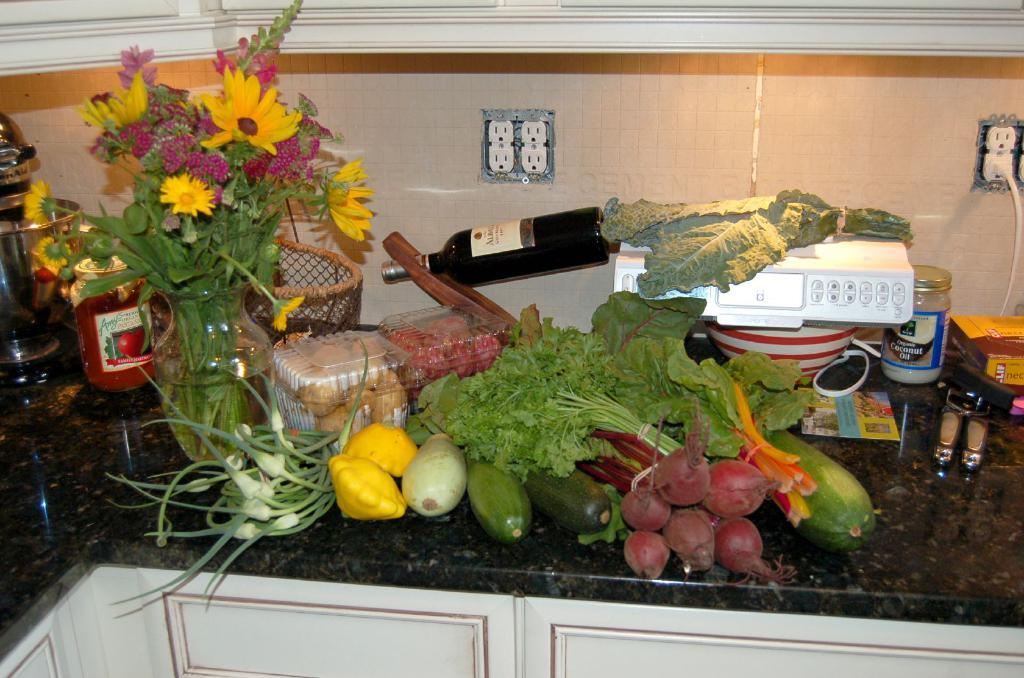What type of food items can be seen in the image? There are vegetables in the image. What type of containers are present in the image? There are boxes in the image. What device is used for measuring weight in the image? There is a weighing machine in the image. What type of decorative item is present in the image? There is a flower vase in the image. What type of liquid containers are on the counter top? There are bottles on the counter top. What type of storage furniture is present in the image? There are cupboards in the image. Who is the expert in the image? There is no expert present in the image. What type of bed can be seen in the image? There is no bed present in the image. 